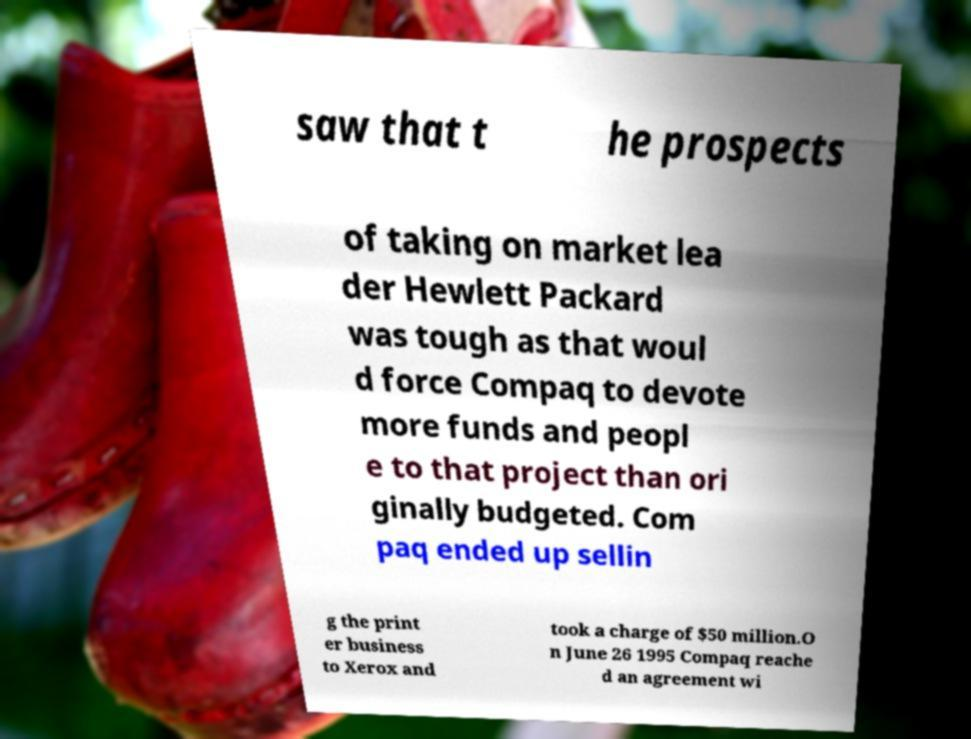Could you extract and type out the text from this image? saw that t he prospects of taking on market lea der Hewlett Packard was tough as that woul d force Compaq to devote more funds and peopl e to that project than ori ginally budgeted. Com paq ended up sellin g the print er business to Xerox and took a charge of $50 million.O n June 26 1995 Compaq reache d an agreement wi 